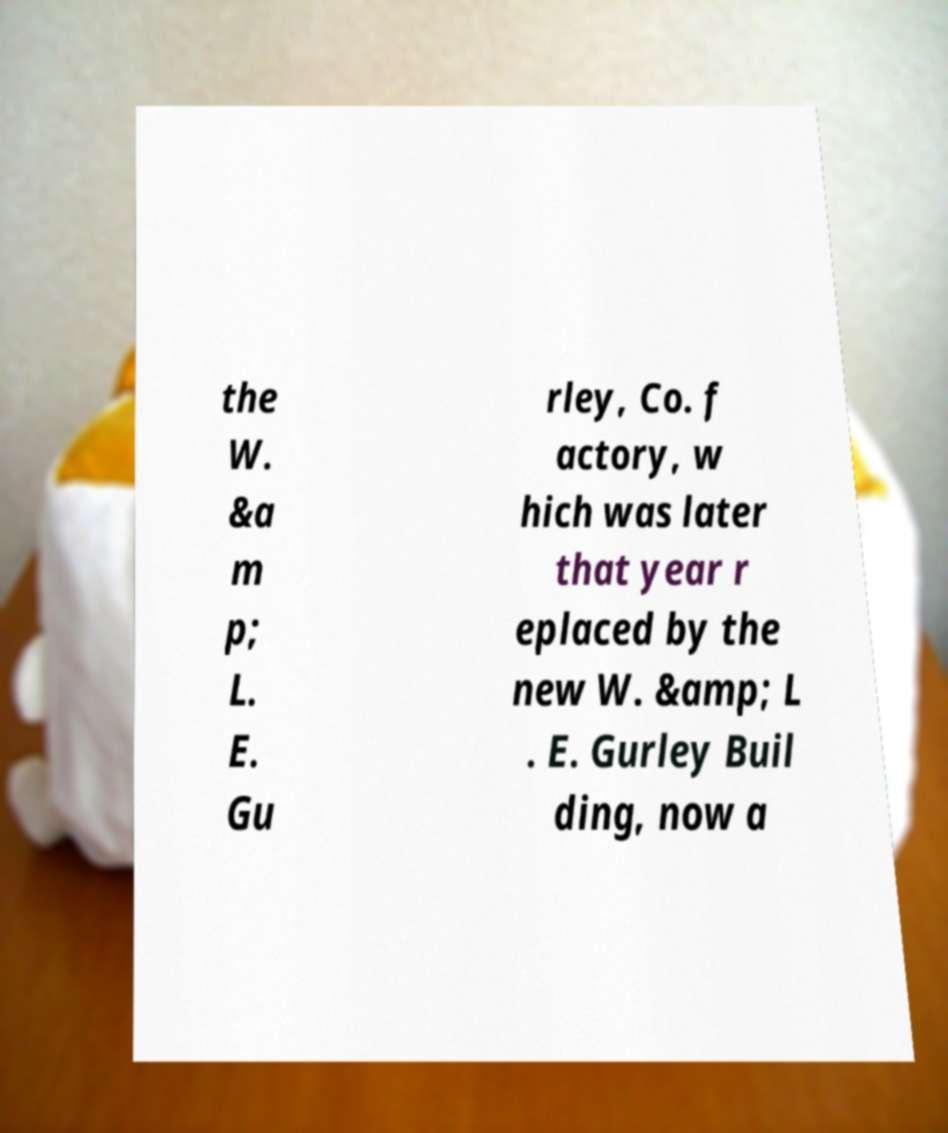For documentation purposes, I need the text within this image transcribed. Could you provide that? the W. &a m p; L. E. Gu rley, Co. f actory, w hich was later that year r eplaced by the new W. &amp; L . E. Gurley Buil ding, now a 